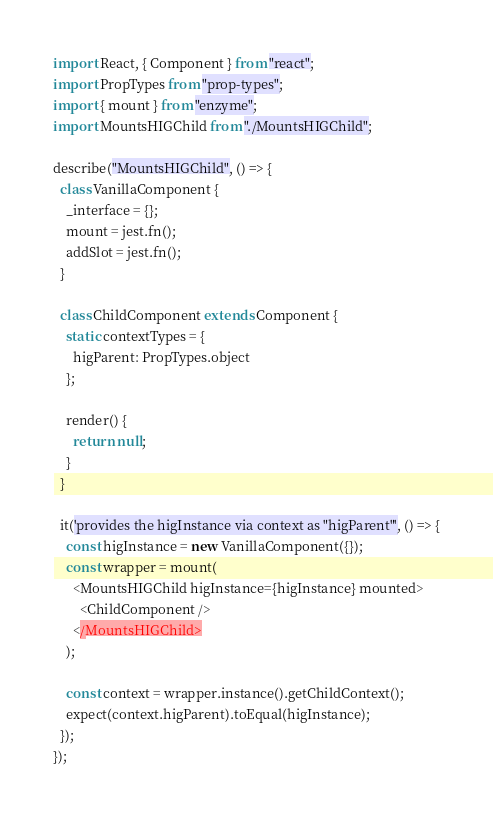<code> <loc_0><loc_0><loc_500><loc_500><_JavaScript_>import React, { Component } from "react";
import PropTypes from "prop-types";
import { mount } from "enzyme";
import MountsHIGChild from "./MountsHIGChild";

describe("MountsHIGChild", () => {
  class VanillaComponent {
    _interface = {};
    mount = jest.fn();
    addSlot = jest.fn();
  }

  class ChildComponent extends Component {
    static contextTypes = {
      higParent: PropTypes.object
    };

    render() {
      return null;
    }
  }

  it('provides the higInstance via context as "higParent"', () => {
    const higInstance = new VanillaComponent({});
    const wrapper = mount(
      <MountsHIGChild higInstance={higInstance} mounted>
        <ChildComponent />
      </MountsHIGChild>
    );

    const context = wrapper.instance().getChildContext();
    expect(context.higParent).toEqual(higInstance);
  });
});
</code> 